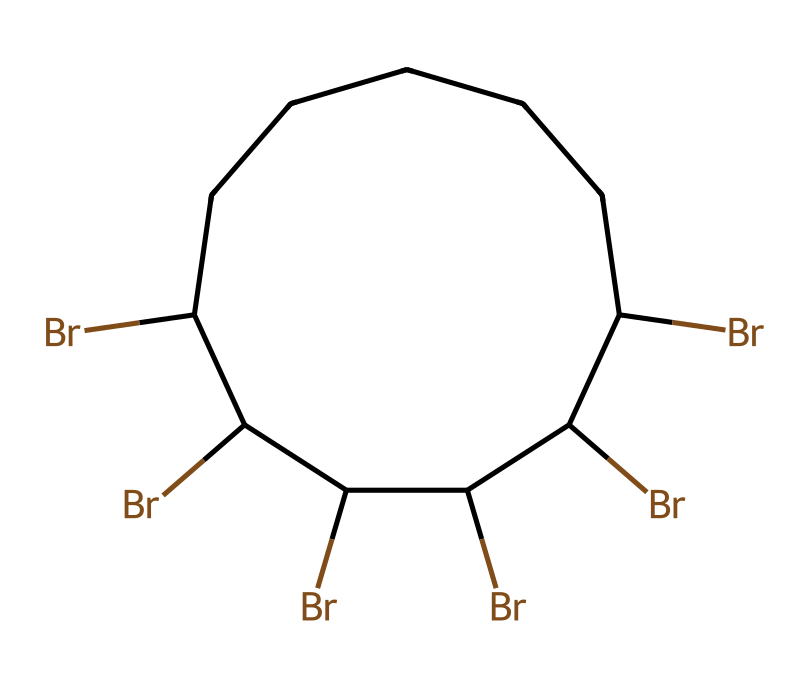What is the total number of carbon atoms in this chemical structure? The SMILES representation shows a cyclic structure beginning with 'C1', indicating the start of a cycle. Each 'C' represents a carbon atom. In total, when counting all 'C' symbols, there are 7 carbon atoms in the structure.
Answer: seven How many bromine atoms are present in this molecule? Each 'Br' represents a bromine atom. By counting the occurrences of 'Br' in the SMILES, we find there are 6 separate 'Br' symbols.
Answer: six What type of chemical is represented by this structure? The chemical has multiple bromine atoms bonded to a hydrocarbon framework, indicating that it is a brominated alkane, specifically a halogenated compound.
Answer: brominated alkane Is the molecule considered saturated or unsaturated? To determine saturation, we observe that the structure has a cyclic arrangement with only single bonds (indicated by the absence of double or triple bonds). Thus, it is saturated.
Answer: saturated Which atom in this structure contributes to its flame-retardant properties? The presence of bromine atoms is key; halogens like bromine are well-known for their flame-retardant properties, as they inhibit combustion.
Answer: bromine How many total atoms (including all types) does this molecule have? We count 7 carbon atoms and 6 bromine atoms. Adding them together gives a total of 13 atoms in the molecule.
Answer: thirteen What is the implication of having multiple bromine atoms in terms of toxicity? Multiple bromine atoms typically increase the potential for toxicity, as brominated compounds can release harmful substances upon combustion or degradation, raising safety concerns in housing materials.
Answer: toxicity 